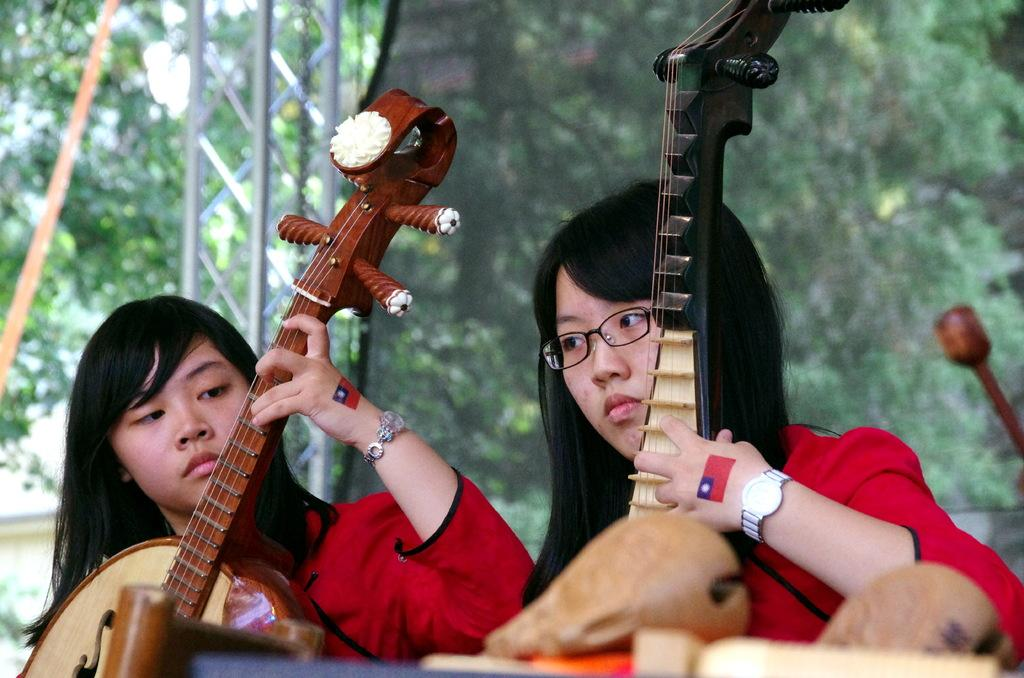How many people are in the image? There are two girls in the image. What are the girls holding in the image? The girls are holding a piano. Can you describe any accessories the girls are wearing? One of the girls is wearing a watch, and one of the girls is wearing spectacles. What type of cannon is being fired in the image? There is no cannon present in the image; it features two girls holding a piano. How does the fiction in the image contribute to the story? There is no fiction present in the image; it is a photograph of two girls holding a piano. 